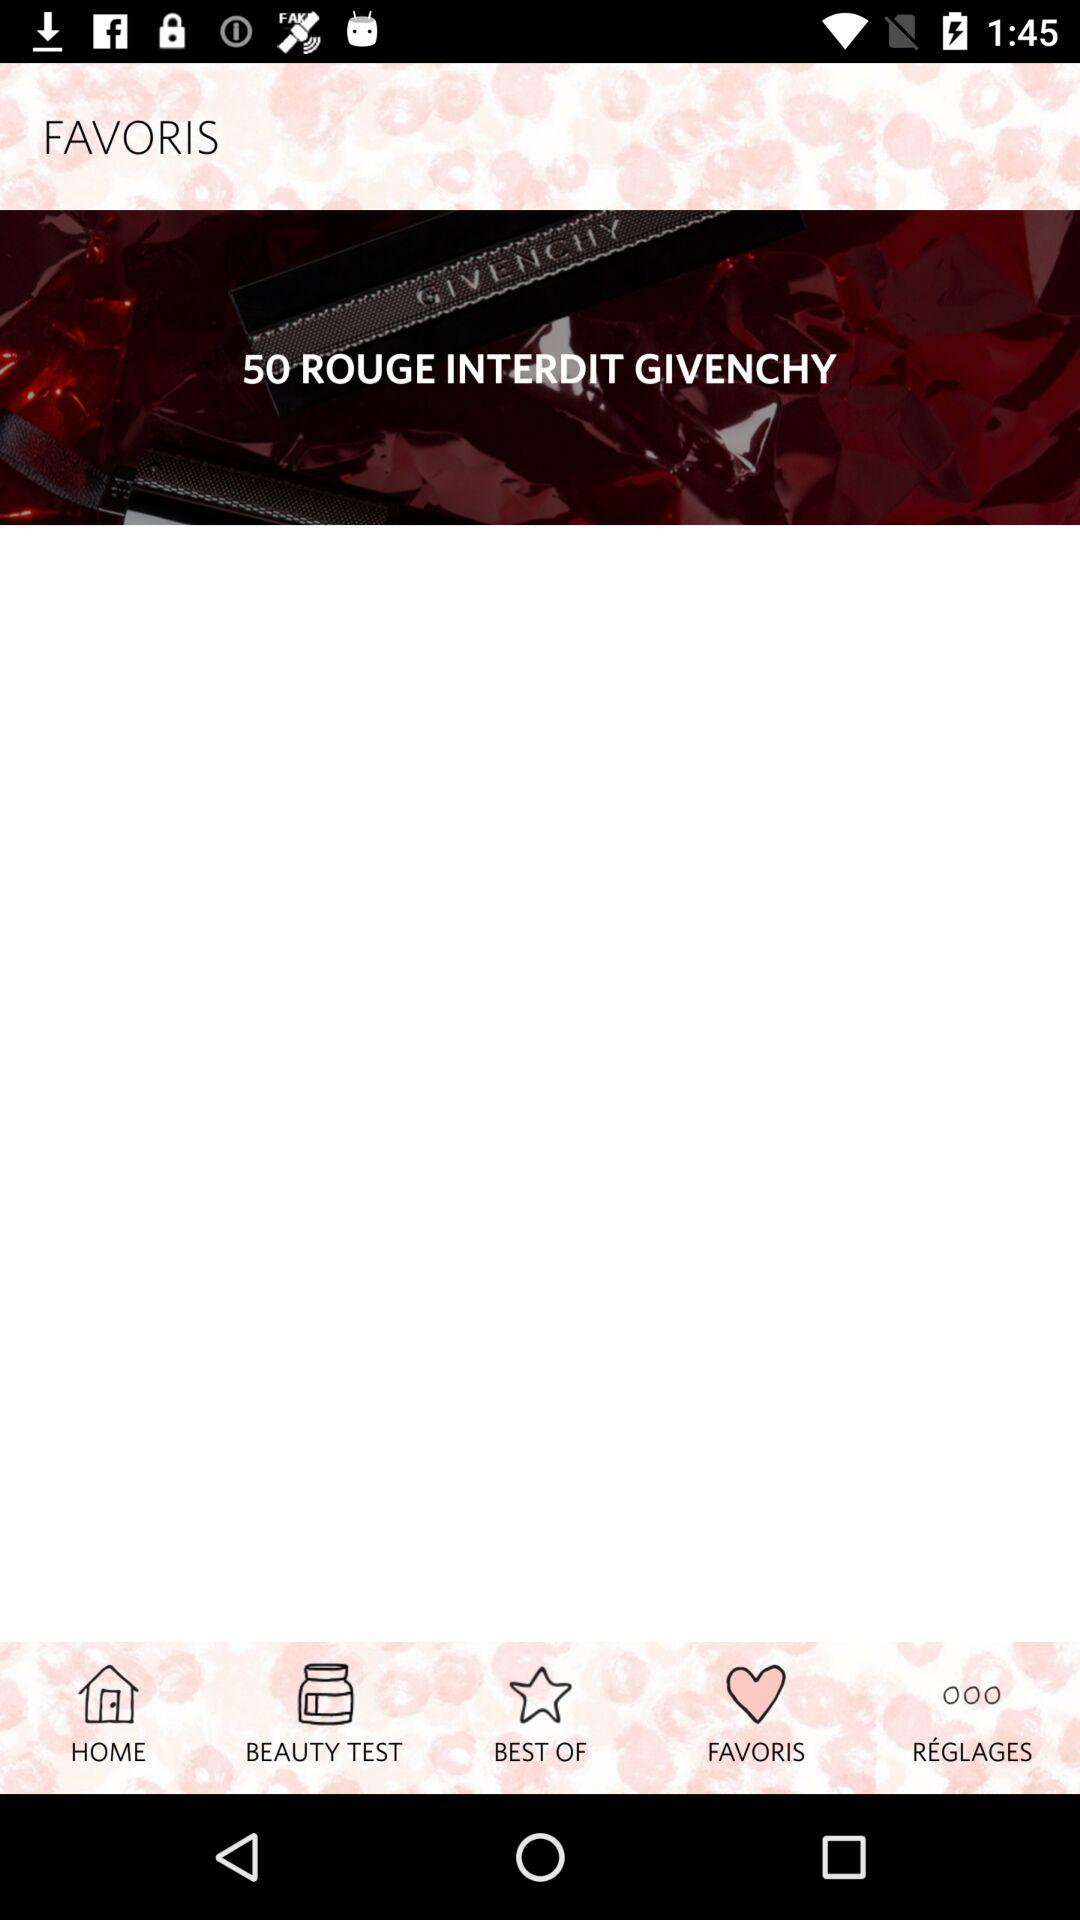What is the name of the application? The name of the application is "FAVORIS". 